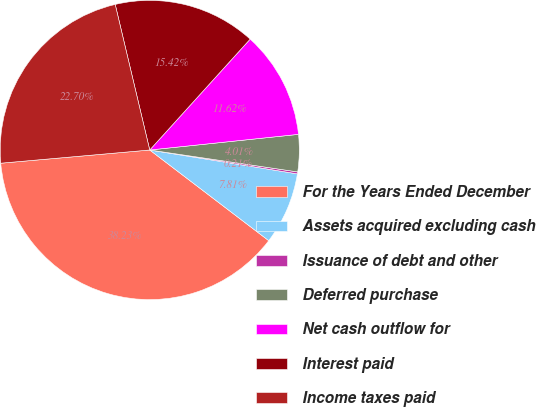<chart> <loc_0><loc_0><loc_500><loc_500><pie_chart><fcel>For the Years Ended December<fcel>Assets acquired excluding cash<fcel>Issuance of debt and other<fcel>Deferred purchase<fcel>Net cash outflow for<fcel>Interest paid<fcel>Income taxes paid<nl><fcel>38.23%<fcel>7.81%<fcel>0.21%<fcel>4.01%<fcel>11.62%<fcel>15.42%<fcel>22.7%<nl></chart> 